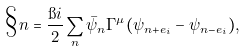Convert formula to latex. <formula><loc_0><loc_0><loc_500><loc_500>\S n = \frac { \i i } { 2 } \sum _ { n } \bar { \psi } _ { n } \Gamma ^ { \mu } ( \psi _ { n + e _ { i } } - \psi _ { n - e _ { i } } ) ,</formula> 